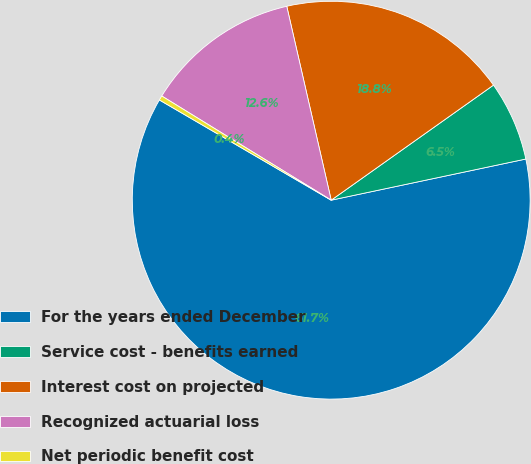<chart> <loc_0><loc_0><loc_500><loc_500><pie_chart><fcel>For the years ended December<fcel>Service cost - benefits earned<fcel>Interest cost on projected<fcel>Recognized actuarial loss<fcel>Net periodic benefit cost<nl><fcel>61.72%<fcel>6.5%<fcel>18.77%<fcel>12.64%<fcel>0.37%<nl></chart> 